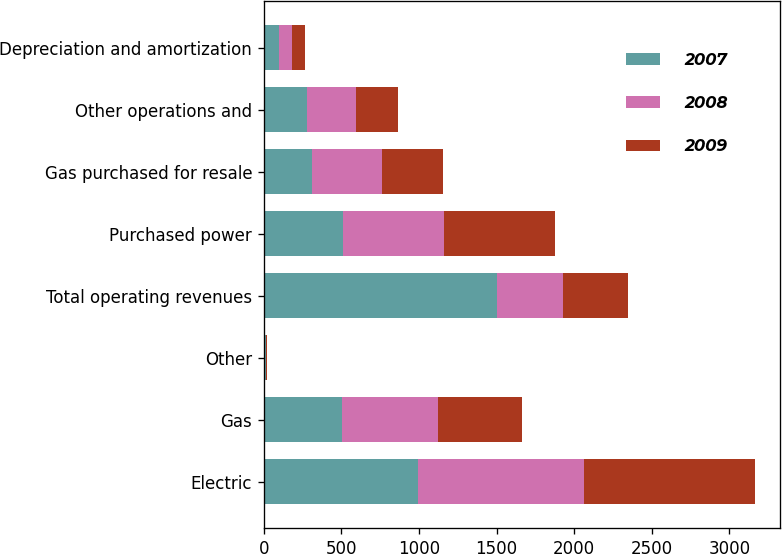Convert chart. <chart><loc_0><loc_0><loc_500><loc_500><stacked_bar_chart><ecel><fcel>Electric<fcel>Gas<fcel>Other<fcel>Total operating revenues<fcel>Purchased power<fcel>Gas purchased for resale<fcel>Other operations and<fcel>Depreciation and amortization<nl><fcel>2007<fcel>992<fcel>501<fcel>11<fcel>1504<fcel>509<fcel>310<fcel>275<fcel>99<nl><fcel>2008<fcel>1071<fcel>620<fcel>5<fcel>421<fcel>654<fcel>452<fcel>318<fcel>85<nl><fcel>2009<fcel>1104<fcel>540<fcel>2<fcel>421<fcel>714<fcel>390<fcel>271<fcel>80<nl></chart> 